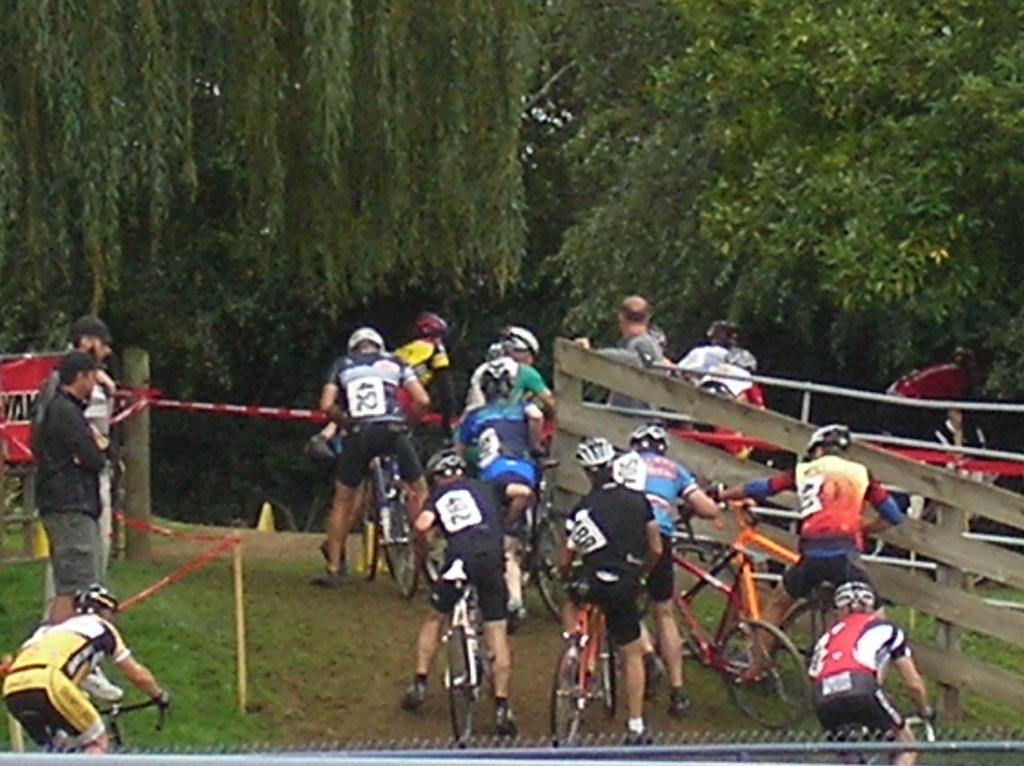Describe this image in one or two sentences. In the image in the center we can see few people were riding cycle and they were wearing helmet. On the left side,there is a banner and few people were standing. In the background we can see trees,grass,fences etc. 